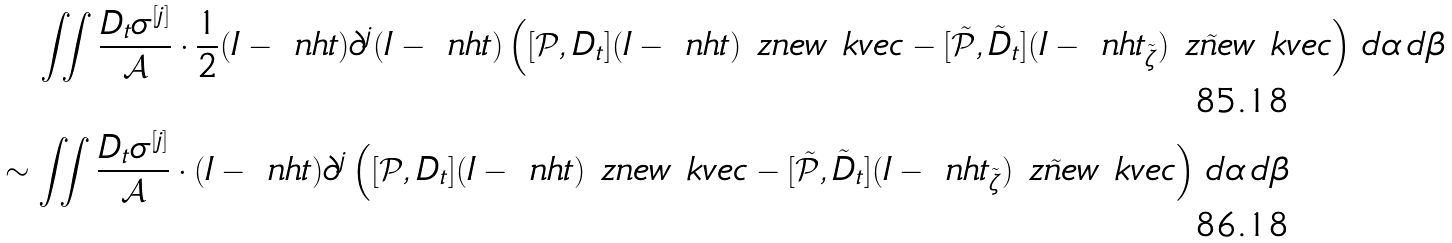<formula> <loc_0><loc_0><loc_500><loc_500>& \quad \iint \frac { D _ { t } \sigma ^ { [ j ] } } { \mathcal { A } } \cdot \frac { 1 } { 2 } ( I - \ n h t ) \partial ^ { j } ( I - \ n h t ) \left ( [ \mathcal { P } , D _ { t } ] ( I - \ n h t ) \ z n e w \ k v e c - [ \tilde { \mathcal { P } } , \tilde { D } _ { t } ] ( I - \ n h t _ { \tilde { \zeta } } ) \tilde { \ z n e w } \ k v e c \right ) \, d \alpha \, d \beta \\ & \sim \iint \frac { D _ { t } \sigma ^ { [ j ] } } { \mathcal { A } } \cdot ( I - \ n h t ) \partial ^ { j } \left ( [ \mathcal { P } , D _ { t } ] ( I - \ n h t ) \ z n e w \ k v e c - [ \tilde { \mathcal { P } } , \tilde { D } _ { t } ] ( I - \ n h t _ { \tilde { \zeta } } ) \tilde { \ z n e w } \ k v e c \right ) \, d \alpha \, d \beta</formula> 